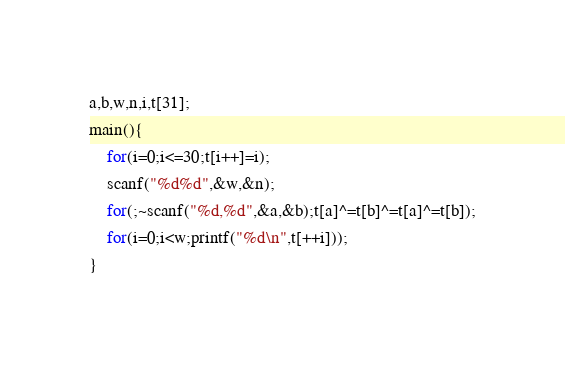<code> <loc_0><loc_0><loc_500><loc_500><_C_>a,b,w,n,i,t[31];
main(){
    for(i=0;i<=30;t[i++]=i);
    scanf("%d%d",&w,&n);
    for(;~scanf("%d,%d",&a,&b);t[a]^=t[b]^=t[a]^=t[b]);
    for(i=0;i<w;printf("%d\n",t[++i]));
}</code> 